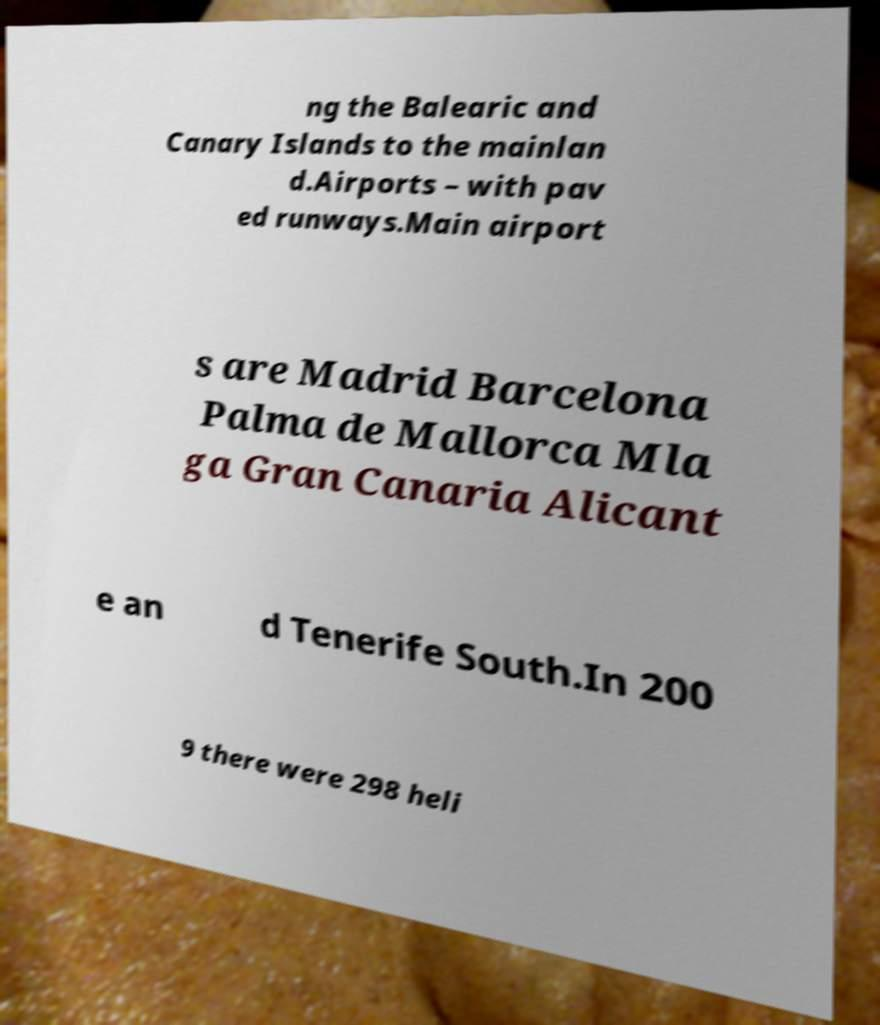What messages or text are displayed in this image? I need them in a readable, typed format. ng the Balearic and Canary Islands to the mainlan d.Airports – with pav ed runways.Main airport s are Madrid Barcelona Palma de Mallorca Mla ga Gran Canaria Alicant e an d Tenerife South.In 200 9 there were 298 heli 